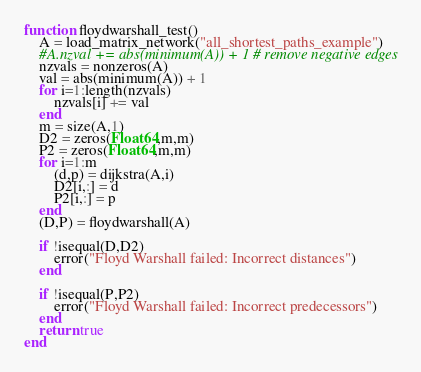<code> <loc_0><loc_0><loc_500><loc_500><_Julia_>function floydwarshall_test()
    A = load_matrix_network("all_shortest_paths_example")
    #A.nzval += abs(minimum(A)) + 1 # remove negative edges
    nzvals = nonzeros(A)
    val = abs(minimum(A)) + 1
    for i=1:length(nzvals)
        nzvals[i] += val
    end 
    m = size(A,1)
    D2 = zeros(Float64,m,m)
    P2 = zeros(Float64,m,m)
    for i=1:m
        (d,p) = dijkstra(A,i)
        D2[i,:] = d
        P2[i,:] = p
    end
    (D,P) = floydwarshall(A)
    
    if !isequal(D,D2)
        error("Floyd Warshall failed: Incorrect distances")
    end
    
    if !isequal(P,P2)
        error("Floyd Warshall failed: Incorrect predecessors")
    end
    return true
end</code> 